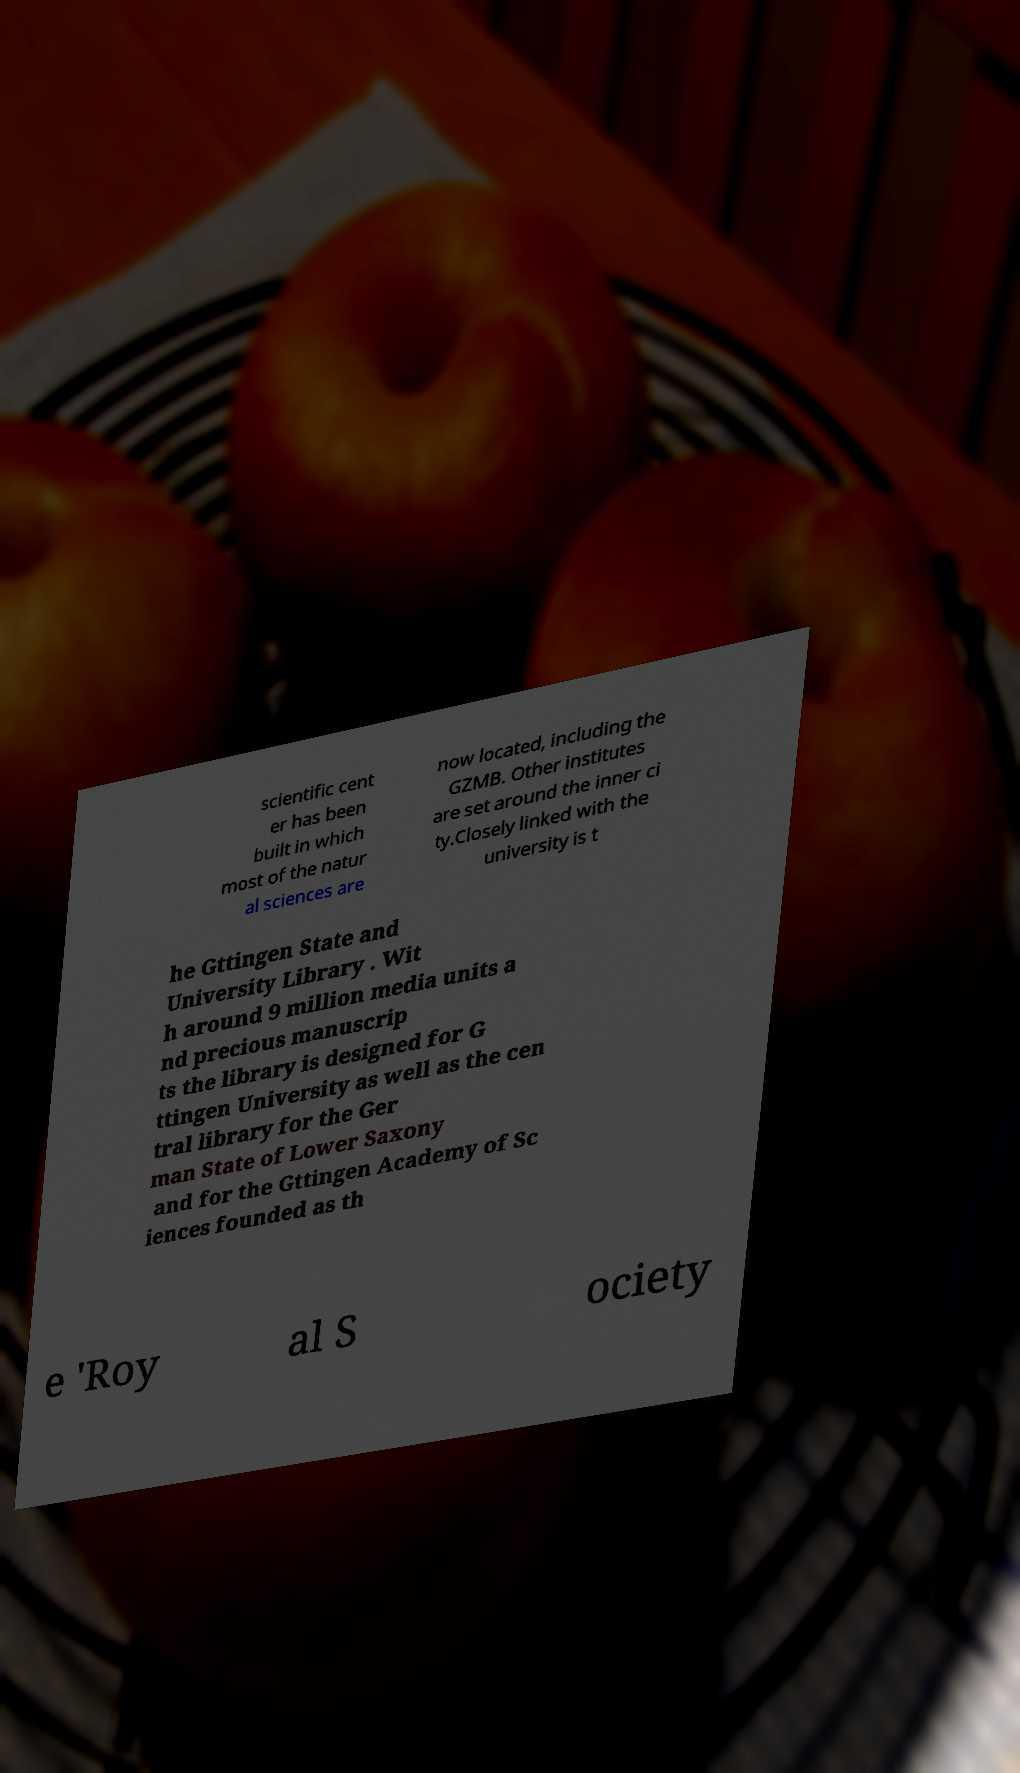Could you assist in decoding the text presented in this image and type it out clearly? scientific cent er has been built in which most of the natur al sciences are now located, including the GZMB. Other institutes are set around the inner ci ty.Closely linked with the university is t he Gttingen State and University Library . Wit h around 9 million media units a nd precious manuscrip ts the library is designed for G ttingen University as well as the cen tral library for the Ger man State of Lower Saxony and for the Gttingen Academy of Sc iences founded as th e 'Roy al S ociety 